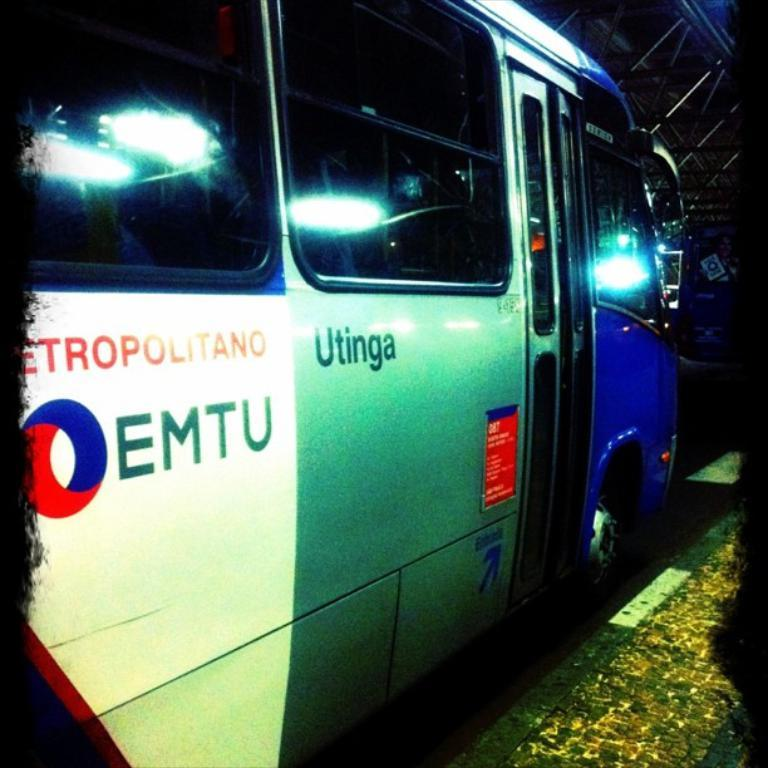What is the main subject of the image? The main subject of the image is a bus. Can you describe the colors of the bus? The bus has white, grey, and blue colors. What feature of the bus is mentioned in the transcript? The bus has windows, which are referred to as "glasses" in the transcript. What can be seen at the bottom of the image? There is a footpath at the bottom of the image. What type of breakfast is being served on the bus in the image? There is no breakfast being served on the bus in the image; it only shows the exterior of the bus. 